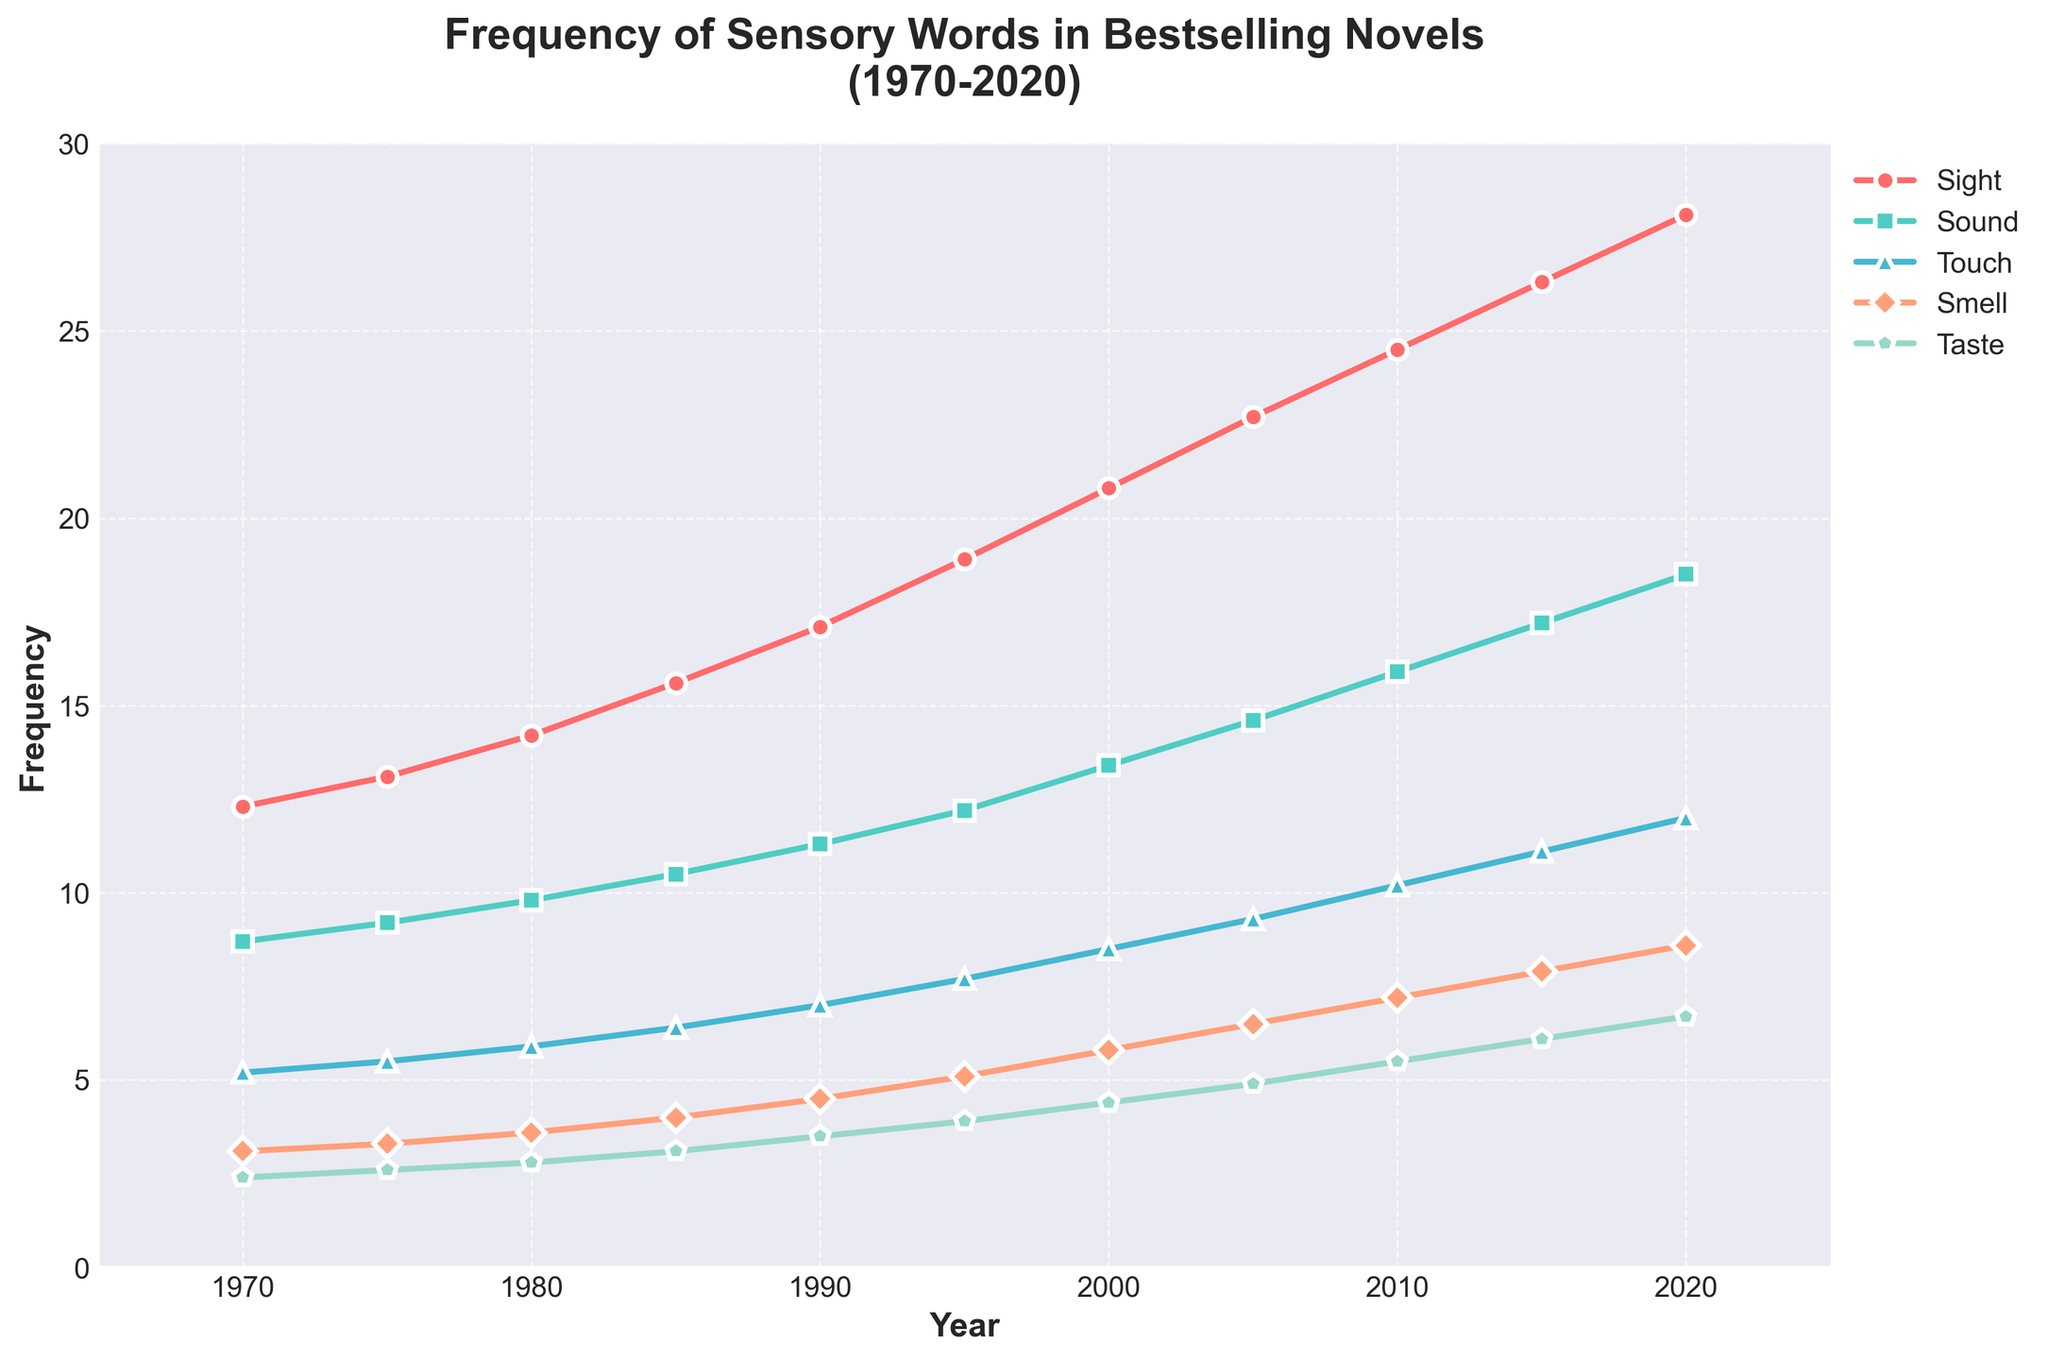Which sense showed the greatest increase in frequency from 1970 to 2020? First, identify the frequencies in 1970 and 2020 for each sense. Then, calculate the difference for each sense (2020 frequency - 1970 frequency). The greatest difference indicates the greatest increase.
Answer: Sight Which year had the highest frequency of touch-related sensory words? Observe the line representing "Touch" and find the peak value. Identify the corresponding year on the X-axis.
Answer: 2020 By how much did the frequency of smell-related sensory words increase from 1990 to 2010? Find the values for smell in 1990 and in 2010. Subtract the 1990 value from the 2010 value (7.2 - 4.5).
Answer: 2.7 On average, how much did the frequency of taste-related sensory words increase per decade? Find the initial and final frequencies for taste (1970 and 2020). Calculate the total increase (6.7 - 2.4). Divide this total increase by the number of decades (5 decades from 1970 to 2020).
Answer: 0.86 Which sense had the smallest growth rate over the entire period? Calculate the difference in frequency from 1970 to 2020 for each sense. The smallest difference represents the smallest growth rate.
Answer: Taste In which period did the frequency of sight-related sensory words increase the most rapidly? Compare the slope of the line representing sight between each pair of consecutive data points and identify where the largest slope (increase) occurs.
Answer: 2000-2005 What was the total frequency of all sensory words in 1985? Add up the frequencies for all senses in 1985 (15.6 + 10.5 + 6.4 + 4.0 + 3.1).
Answer: 39.6 Is there any overlap in the frequencies of sound and smell-related words between 1970 and 2020? Compare the frequencies of sound and smell year by year to check if their values ever intersect or overlap.
Answer: No How much did the frequency of sight-related words increase from the first to the last year? Subtract the frequency of sight in 1970 from the frequency in 2020 (28.1 - 12.3).
Answer: 15.8 Which sense had the most consistent growth rate over the 50-year period? Evaluate the growth pattern for each sense to identify the one with the most linear or consistent increase by visually inspecting the smoothness of the corresponding lines.
Answer: Sound 